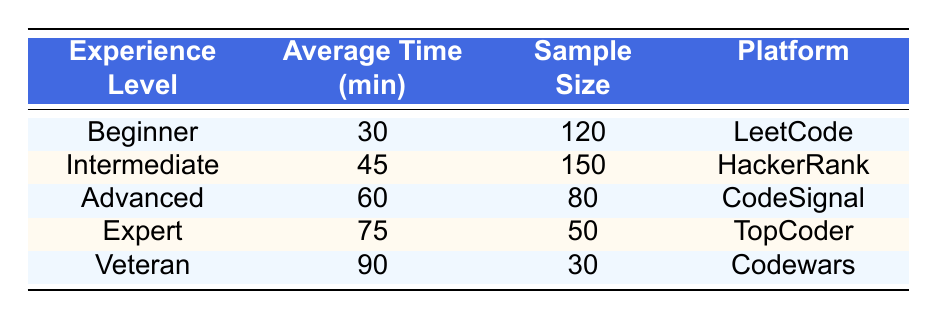What is the average time spent by a Beginner? The table shows that the average time spent by a Beginner is 30 minutes.
Answer: 30 minutes Which experience level has the highest average time spent? The Veteran experience level has the highest average time spent, which is 90 minutes.
Answer: Veteran What is the average time difference between Experts and Intermediate solvers? The average time for Experts is 75 minutes and for Intermediate is 45 minutes. The difference is 75 - 45 = 30 minutes.
Answer: 30 minutes Is the sample size for Advanced solvers greater than that of Veterans? The sample size for Advanced is 80, and for Veterans, it is 30. Since 80 is greater than 30, the answer is yes.
Answer: Yes What is the combined average time spent by Beginners and Intermediate solvers? The average time for Beginners is 30 minutes and for Intermediate solvers is 45 minutes. Therefore, the combined average is (30 + 45) / 2 = 37.5 minutes.
Answer: 37.5 minutes How many total minutes do all experience levels spend solving puzzles on average? The average times for all levels are 30, 45, 60, 75, and 90 minutes. Adding these gives 30 + 45 + 60 + 75 + 90 = 300 minutes.
Answer: 300 minutes Is the average time spent by Veterans more than the average time spent by Beginners and Intermediate combined? The average time for Veterans is 90 minutes, while the combined average for Beginners (30) and Intermediate (45) is 30 + 45 = 75 minutes. Since 90 is greater than 75, the answer is yes.
Answer: Yes What percentage of the sample size does the Intermediate experience level represent compared to the total? The sample size for Intermediate is 150, and the total sample size (120 + 150 + 80 + 50 + 30) is 430. The percentage is (150 / 430) * 100 = 34.88%.
Answer: 34.88% Which platform has the lowest average time spent solving puzzles? The platform with the lowest average time spent is LeetCode, associated with Beginners, which is 30 minutes.
Answer: LeetCode 